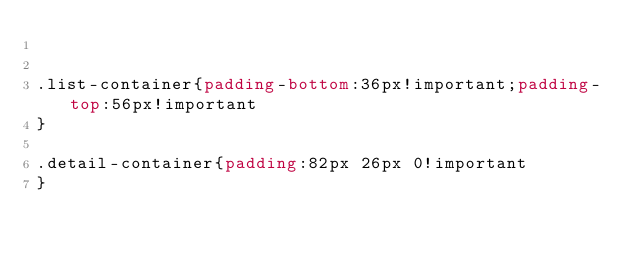<code> <loc_0><loc_0><loc_500><loc_500><_CSS_>

.list-container{padding-bottom:36px!important;padding-top:56px!important
}

.detail-container{padding:82px 26px 0!important
}
</code> 